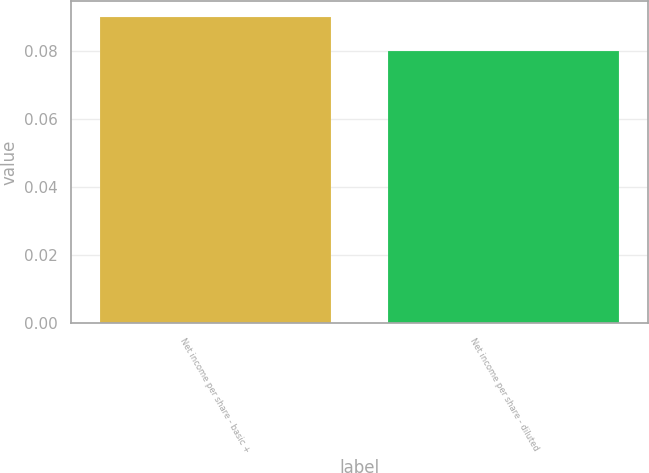Convert chart to OTSL. <chart><loc_0><loc_0><loc_500><loc_500><bar_chart><fcel>Net income per share - basic +<fcel>Net income per share - diluted<nl><fcel>0.09<fcel>0.08<nl></chart> 